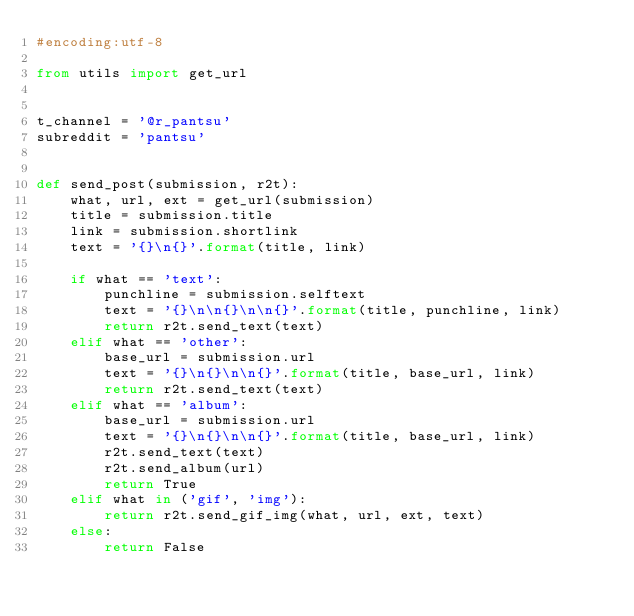<code> <loc_0><loc_0><loc_500><loc_500><_Python_>#encoding:utf-8

from utils import get_url


t_channel = '@r_pantsu'
subreddit = 'pantsu'


def send_post(submission, r2t):
    what, url, ext = get_url(submission)
    title = submission.title
    link = submission.shortlink
    text = '{}\n{}'.format(title, link)

    if what == 'text':
        punchline = submission.selftext
        text = '{}\n\n{}\n\n{}'.format(title, punchline, link)
        return r2t.send_text(text)
    elif what == 'other':
        base_url = submission.url
        text = '{}\n{}\n\n{}'.format(title, base_url, link)
        return r2t.send_text(text)
    elif what == 'album':
        base_url = submission.url
        text = '{}\n{}\n\n{}'.format(title, base_url, link)
        r2t.send_text(text)
        r2t.send_album(url)
        return True
    elif what in ('gif', 'img'):
        return r2t.send_gif_img(what, url, ext, text)
    else:
        return False
</code> 